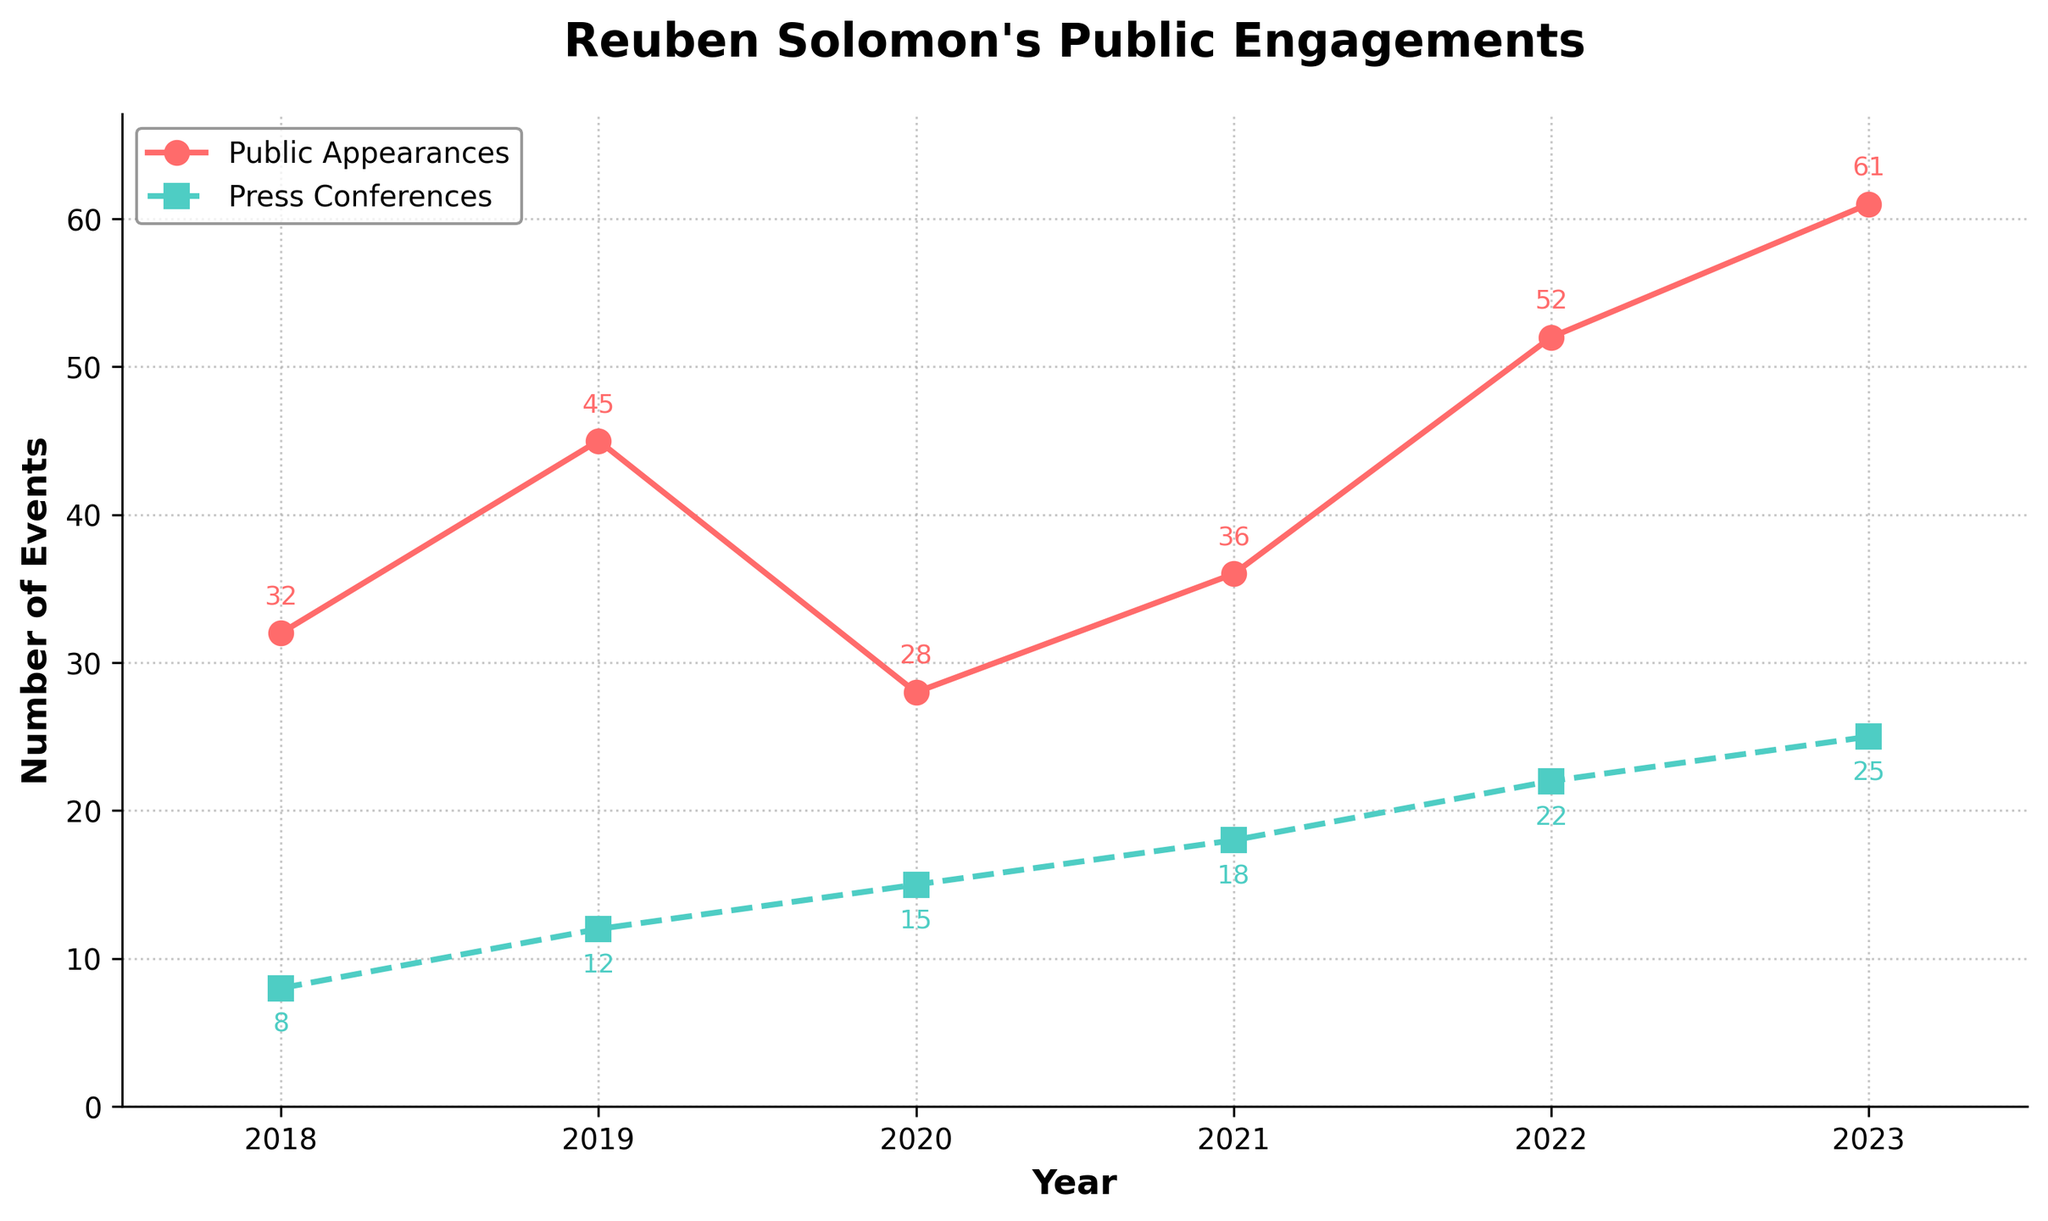What's the total number of public appearances and press conferences combined in 2021? First, find the number of public appearances and press conferences in 2021; they are 36 and 18 respectively. Then add them together: 36 + 18 = 54
Answer: 54 During which year did Reuben Solomon hold the fewest public appearances? Look at the data points for public appearances across all years and identify the smallest number. The smallest number is 28 in 2020
Answer: 2020 How many more public appearances were there in 2023 compared to 2020? Subtract the number of public appearances in 2020 (28) from the number in 2023 (61). 61 - 28 = 33
Answer: 33 Which year saw the greatest increase in the number of press conferences compared to the previous year? Calculate the difference in press conferences year over year: 2019 (12) - 2018 (8) = 4, 2020 (15) - 2019 (12) = 3, 2021 (18) - 2020 (15) = 3, 2022 (22) - 2021 (18) = 4, 2023 (25) - 2022 (22) = 3. The greatest increase is 4, which occurs between 2018 and 2019 and 2021 and 2022
Answer: 2019 and 2022 In which year were press conferences closest to the number of public appearances? Calculate the difference between public appearances and press conferences for each year: 2018: 32 - 8 = 24, 2019: 45 - 12 = 33, 2020: 28 - 15 = 13, 2021: 36 - 18 = 18, 2022: 52 - 22 = 30, 2023: 61 - 25 = 36. The smallest difference is 13, which occurs in 2020
Answer: 2020 Describe the general trend in the number of public appearances from 2018 to 2023 Observe the overall movement of the line representing public appearances from left to right. It starts at 32 in 2018 and generally increases to 61 in 2023, with a dip in 2020
Answer: Increasing trend Did the number of public appearances increase or decrease from 2019 to 2020? Compare the number of public appearances in 2019 (45) with that in 2020 (28). Since 28 < 45, it decreased
Answer: Decrease What is the difference in the number of press conferences between the highest and lowest years? Identify the highest (2023: 25) and lowest (2018: 8) values for press conferences and subtract the lowest from the highest: 25 - 8 = 17
Answer: 17 How much did the total number of public appearances and press conferences increase from 2021 to 2023? Calculate the sum of public appearances and press conferences for 2021 and 2023: (36 + 18) = 54 for 2021 and (61 + 25) = 86 for 2023. Then find the difference: 86 - 54 = 32
Answer: 32 